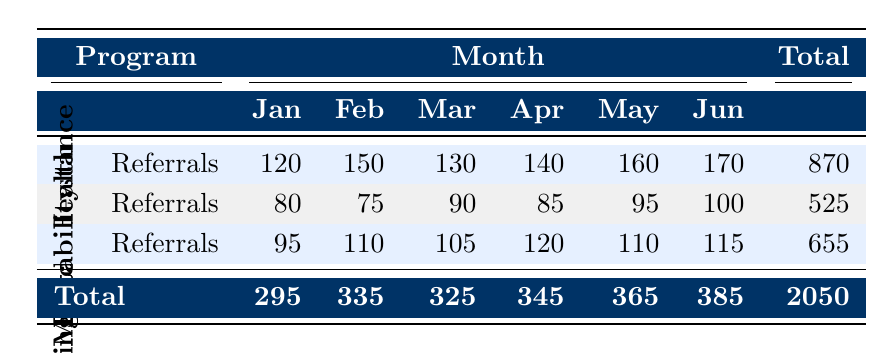What is the total number of referrals for the Food Assistance Program? To find the total referrals for the Food Assistance Program, we sum the values from each month: 120 (Jan) + 150 (Feb) + 130 (Mar) + 140 (Apr) + 160 (May) + 170 (Jun) = 870.
Answer: 870 Which month had the highest number of referrals for the Mental Health Support program? Looking at the table, we can see the referrals for each month: 80 (Jan), 75 (Feb), 90 (Mar), 85 (Apr), 95 (May), 100 (Jun). The highest value is 100 in June.
Answer: June What is the average number of referrals received for Housing Stability Services? We first sum the referrals: 95 (Jan) + 110 (Feb) + 105 (Mar) + 120 (Apr) + 110 (May) + 115 (Jun) = 655. Then, we divide by the number of months (6): 655 / 6 ≈ 109.17.
Answer: 109.17 Did the Food Assistance Program receive more referrals in May than in any other month? The referrals in May are 160. Checking other months: January (120), February (150), March (130), April (140), June (170). Since June (170) is higher, the statement is false.
Answer: No What is the total number of referrals received across all programs in February? To calculate the total for February, we add the referrals from all programs: 150 (Food Assistance) + 75 (Mental Health) + 110 (Housing Stability) = 335.
Answer: 335 Was there an increase in referrals for Food Assistance from March to April? The referrals for March are 130 and for April are 140. We observe that 140 > 130, indicating an increase.
Answer: Yes How many more referrals did the Housing Stability Services receive than the Mental Health Support program in June? In June, Housing Stability Services had 115 referrals, while Mental Health Support had 100. To find the difference, we subtract: 115 - 100 = 15.
Answer: 15 What is the total number of referrals received for all programs in June? We add all referrals in June: 170 (Food Assistance) + 100 (Mental Health) + 115 (Housing Stability) = 385.
Answer: 385 Which social support program consistently received the least referrals each month? By comparing the monthly totals, the Mental Health Support program had the lowest monthly referrals in every month compared to the other programs.
Answer: Mental Health Support 